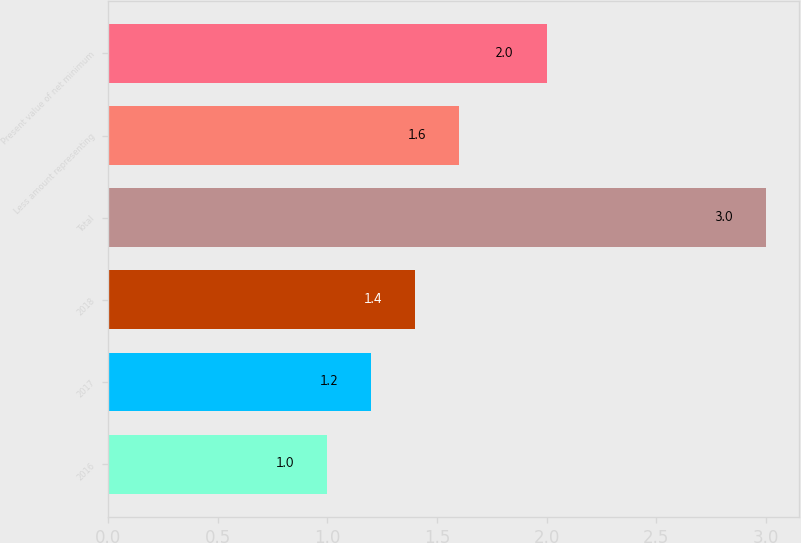<chart> <loc_0><loc_0><loc_500><loc_500><bar_chart><fcel>2016<fcel>2017<fcel>2018<fcel>Total<fcel>Less amount representing<fcel>Present value of net minimum<nl><fcel>1<fcel>1.2<fcel>1.4<fcel>3<fcel>1.6<fcel>2<nl></chart> 